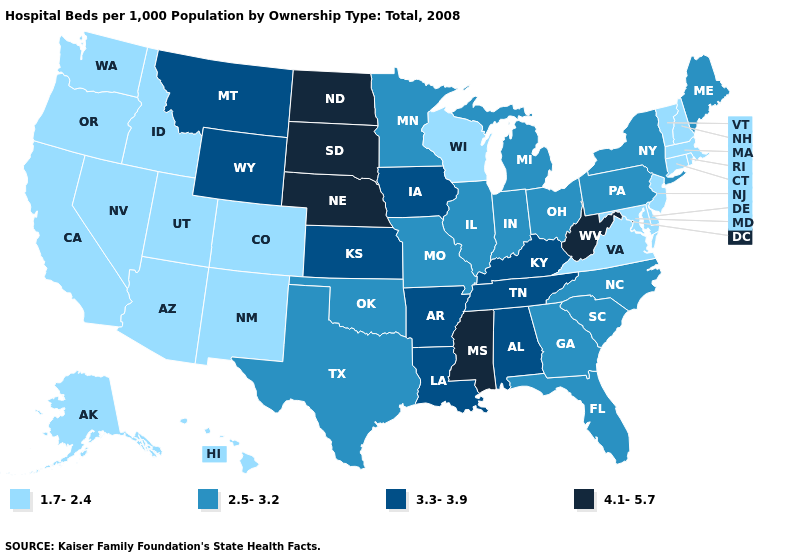What is the highest value in the South ?
Answer briefly. 4.1-5.7. Name the states that have a value in the range 2.5-3.2?
Concise answer only. Florida, Georgia, Illinois, Indiana, Maine, Michigan, Minnesota, Missouri, New York, North Carolina, Ohio, Oklahoma, Pennsylvania, South Carolina, Texas. What is the value of New York?
Keep it brief. 2.5-3.2. Is the legend a continuous bar?
Quick response, please. No. Among the states that border Iowa , does Minnesota have the highest value?
Give a very brief answer. No. Does Nevada have the lowest value in the West?
Write a very short answer. Yes. Which states hav the highest value in the Northeast?
Write a very short answer. Maine, New York, Pennsylvania. What is the value of North Dakota?
Concise answer only. 4.1-5.7. How many symbols are there in the legend?
Be succinct. 4. Which states have the lowest value in the USA?
Give a very brief answer. Alaska, Arizona, California, Colorado, Connecticut, Delaware, Hawaii, Idaho, Maryland, Massachusetts, Nevada, New Hampshire, New Jersey, New Mexico, Oregon, Rhode Island, Utah, Vermont, Virginia, Washington, Wisconsin. Does Colorado have the lowest value in the USA?
Be succinct. Yes. How many symbols are there in the legend?
Answer briefly. 4. Which states hav the highest value in the South?
Quick response, please. Mississippi, West Virginia. What is the value of South Carolina?
Be succinct. 2.5-3.2. 